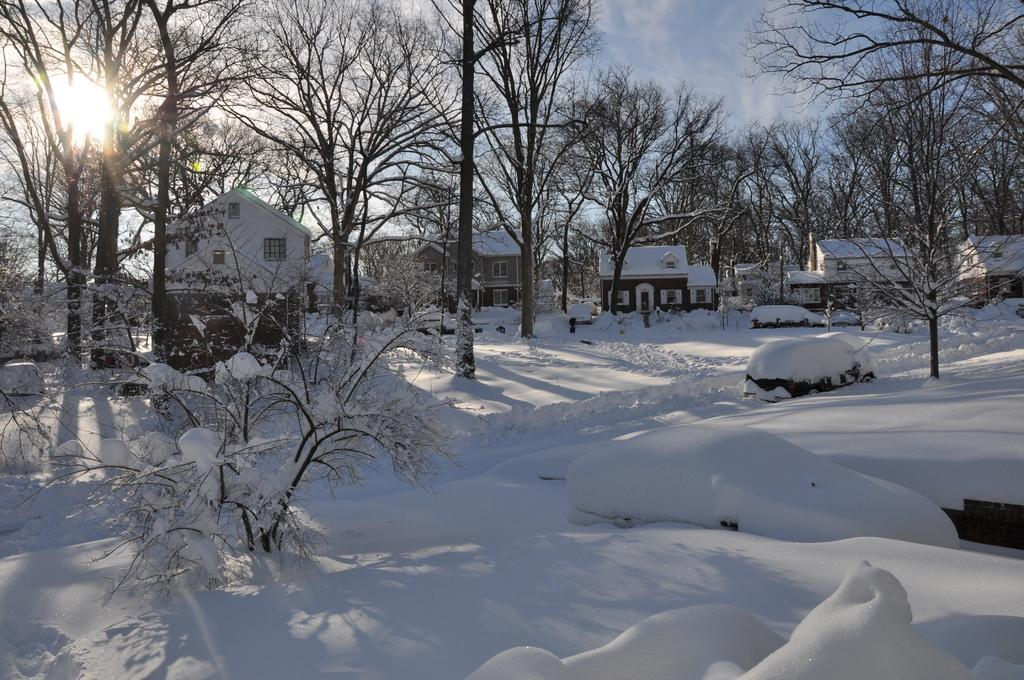What type of structures can be seen in the image? There are houses in the image. What kind of trees are present in the image? Deciduous trees are present in the image. What is covering the vehicles in the image? Snow is visible on vehicles in the image. What is visible in the sky in the image? There are clouds in the sky in the image. What type of muscle is being flexed by the person in the image? There is no person present in the image, so it is not possible to determine what type of muscle might be flexed. 